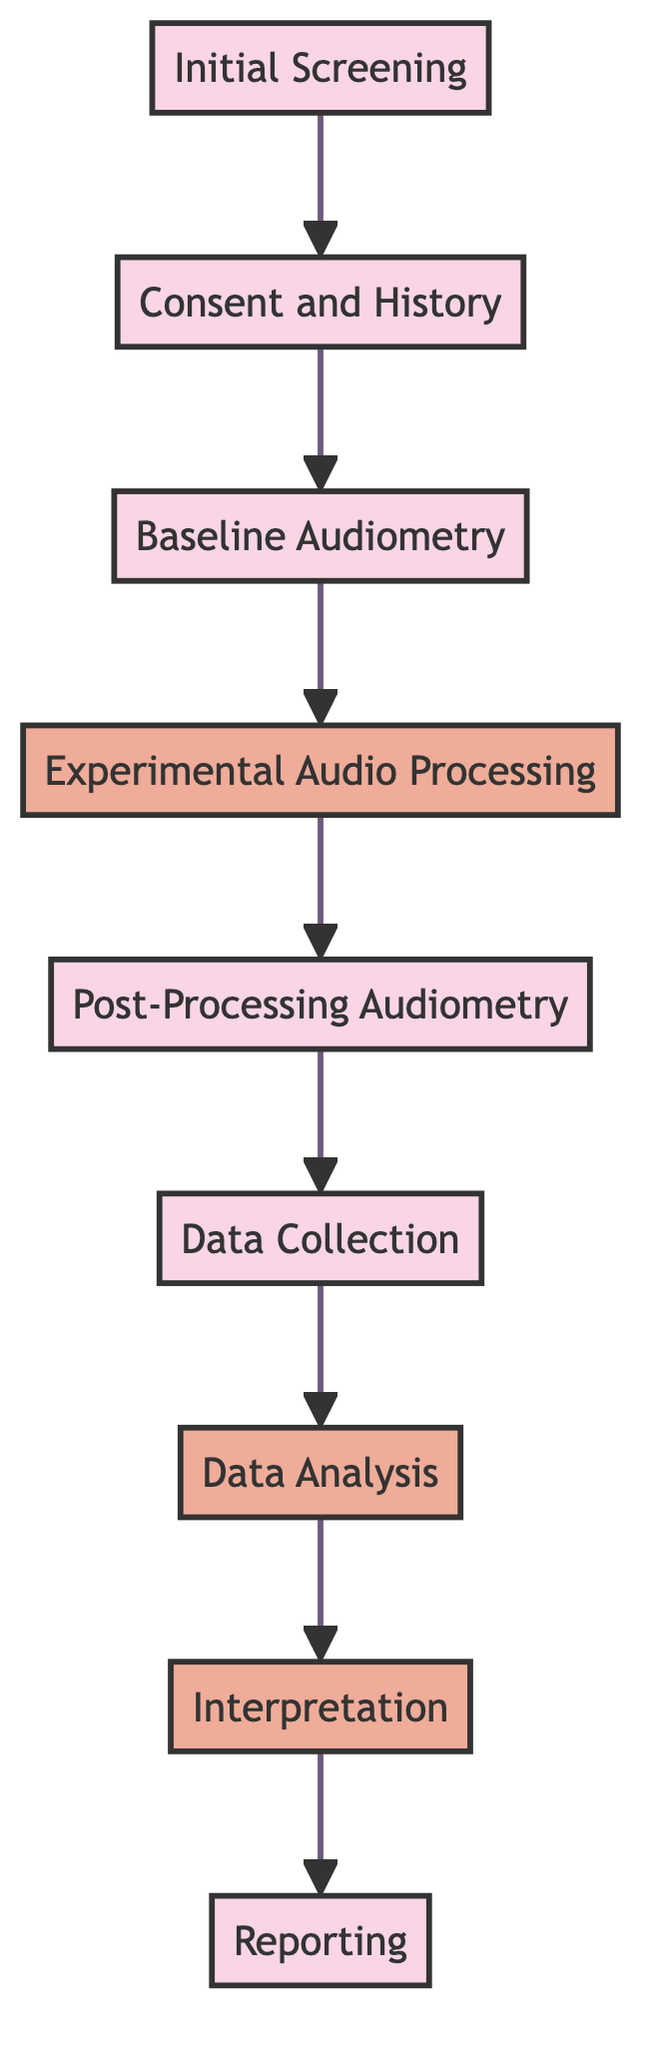What is the first step in the clinical pathway? The first step in the clinical pathway is indicated in the diagram as "Initial Screening," which is the starting point of the process.
Answer: Initial Screening How many steps are outlined in the clinical pathway? By counting the nodes in the diagram, there are a total of nine steps represented in the clinical pathway, starting from initial screening to reporting.
Answer: Nine What follows the "Experimental Audio Processing" step? The diagram shows that after "Experimental Audio Processing," the next step is "Post-Processing Audiometry."
Answer: Post-Processing Audiometry Which steps involve data analysis? The steps "Data Collection" and "Data Analysis" are dedicated to gathering and analyzing the audiometric data, as indicated in the pathway.
Answer: Data Collection, Data Analysis What is the last step in the clinical pathway? The final step displayed in the diagram is "Reporting," which summarizes the findings and implications of the experimental procedures.
Answer: Reporting What is conducted after obtaining consent and history? After obtaining consent and history, the next step is "Baseline Audiometry," where initial hearing thresholds are established.
Answer: Baseline Audiometry How many experimental processing techniques are applied? The pathway indicates that the step "Experimental Audio Processing" involves applying experimental techniques, but it does not specify a number; it focuses on audio processing methods.
Answer: One or more techniques What purpose does "Post-Processing Audiometry" serve? This step serves to re-assess hearing and evaluate the effects of the experimental audio processing, ensuring that the impact can be measured.
Answer: Evaluate effects Which two steps analyze data? The steps "Data Analysis" and "Interpretation" work together to analyze the collected data and interpret its implications in the clinical pathway.
Answer: Data Analysis, Interpretation 